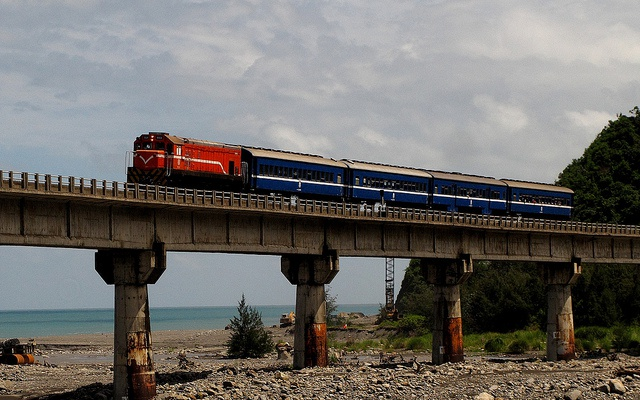Describe the objects in this image and their specific colors. I can see a train in darkgray, black, navy, and brown tones in this image. 